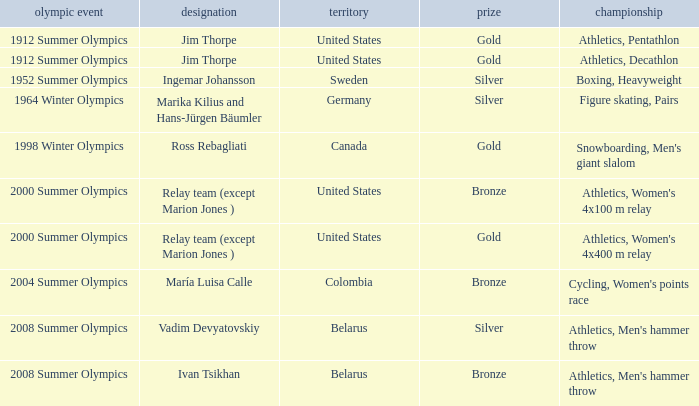What country has a silver medal in the boxing, heavyweight event? Sweden. 